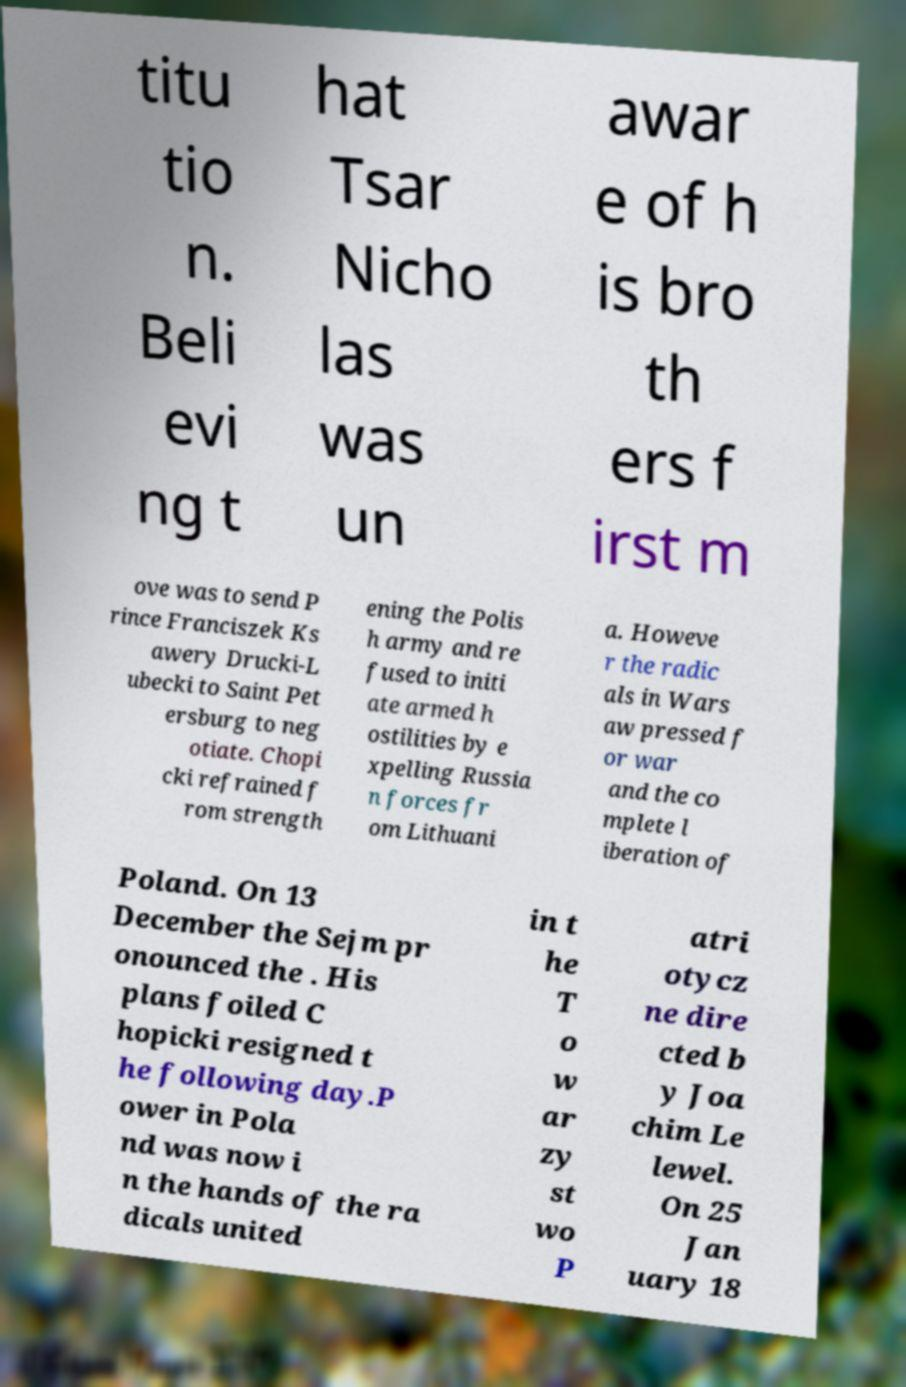What messages or text are displayed in this image? I need them in a readable, typed format. titu tio n. Beli evi ng t hat Tsar Nicho las was un awar e of h is bro th ers f irst m ove was to send P rince Franciszek Ks awery Drucki-L ubecki to Saint Pet ersburg to neg otiate. Chopi cki refrained f rom strength ening the Polis h army and re fused to initi ate armed h ostilities by e xpelling Russia n forces fr om Lithuani a. Howeve r the radic als in Wars aw pressed f or war and the co mplete l iberation of Poland. On 13 December the Sejm pr onounced the . His plans foiled C hopicki resigned t he following day.P ower in Pola nd was now i n the hands of the ra dicals united in t he T o w ar zy st wo P atri otycz ne dire cted b y Joa chim Le lewel. On 25 Jan uary 18 